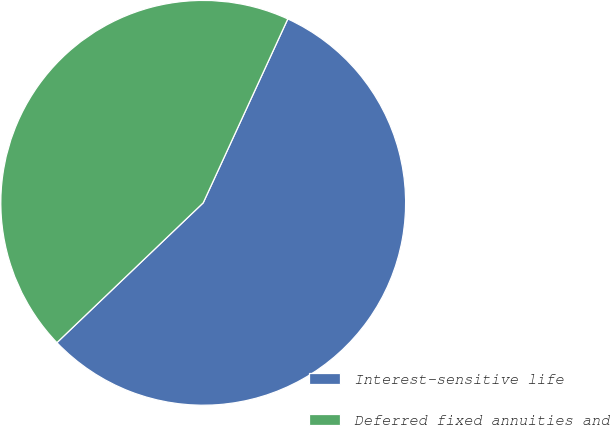Convert chart. <chart><loc_0><loc_0><loc_500><loc_500><pie_chart><fcel>Interest-sensitive life<fcel>Deferred fixed annuities and<nl><fcel>56.0%<fcel>44.0%<nl></chart> 